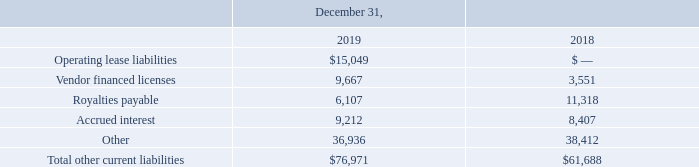Other Current Liabilities
The components of other current liabilities are included in the following table (in thousands):
What were the operating lease liabilities in 2019?
Answer scale should be: thousand. $15,049. What were the royalties payable in 2019?
Answer scale should be: thousand. 6,107. What were the royalties payable in 2018?
Answer scale should be: thousand. 11,318. What was the change in vendor financed licenses between 2018 and 2019?
Answer scale should be: thousand. 9,667-3,551
Answer: 6116. What was the change in accrued interest between 2018 and 2019?
Answer scale should be: thousand. 9,212-8,407
Answer: 805. What was the percentage change in total other current liabilities between 2018 and 2019?
Answer scale should be: percent. ($76,971-$61,688)/$61,688
Answer: 24.77. 